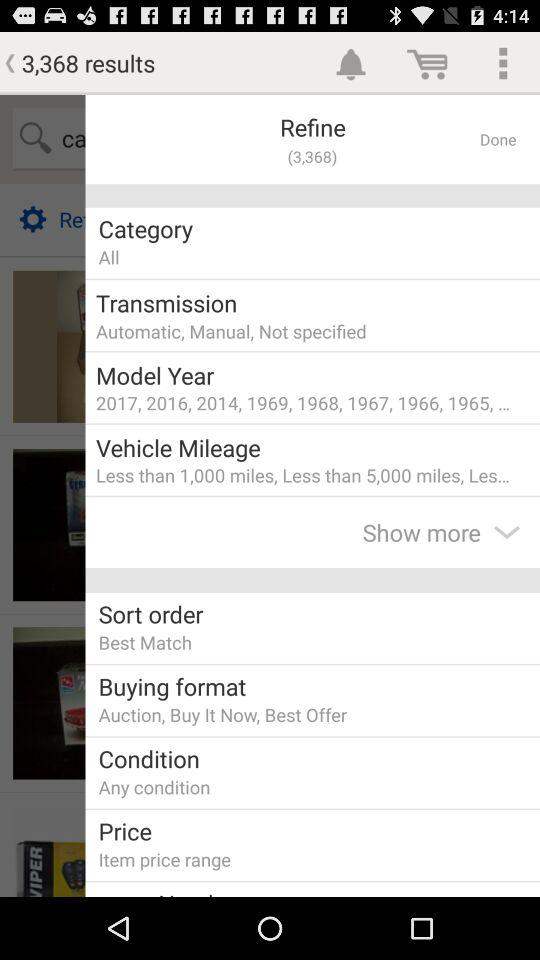What is the model year? The model years are 2017, 2016, 2014, 1969, 1968, 1967, 1966, 1965 and so on. 